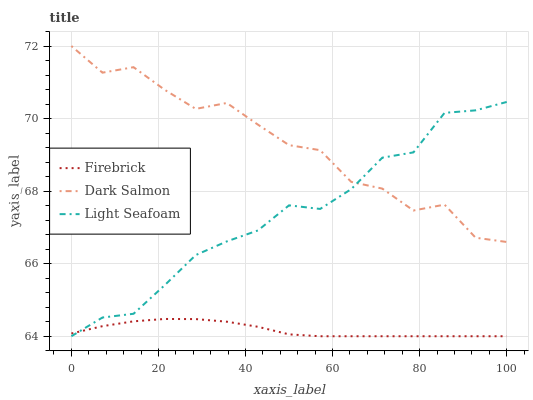Does Firebrick have the minimum area under the curve?
Answer yes or no. Yes. Does Dark Salmon have the maximum area under the curve?
Answer yes or no. Yes. Does Light Seafoam have the minimum area under the curve?
Answer yes or no. No. Does Light Seafoam have the maximum area under the curve?
Answer yes or no. No. Is Firebrick the smoothest?
Answer yes or no. Yes. Is Dark Salmon the roughest?
Answer yes or no. Yes. Is Light Seafoam the smoothest?
Answer yes or no. No. Is Light Seafoam the roughest?
Answer yes or no. No. Does Dark Salmon have the lowest value?
Answer yes or no. No. Does Dark Salmon have the highest value?
Answer yes or no. Yes. Does Light Seafoam have the highest value?
Answer yes or no. No. Is Firebrick less than Dark Salmon?
Answer yes or no. Yes. Is Dark Salmon greater than Firebrick?
Answer yes or no. Yes. Does Light Seafoam intersect Firebrick?
Answer yes or no. Yes. Is Light Seafoam less than Firebrick?
Answer yes or no. No. Is Light Seafoam greater than Firebrick?
Answer yes or no. No. Does Firebrick intersect Dark Salmon?
Answer yes or no. No. 